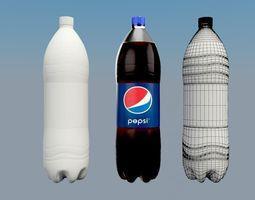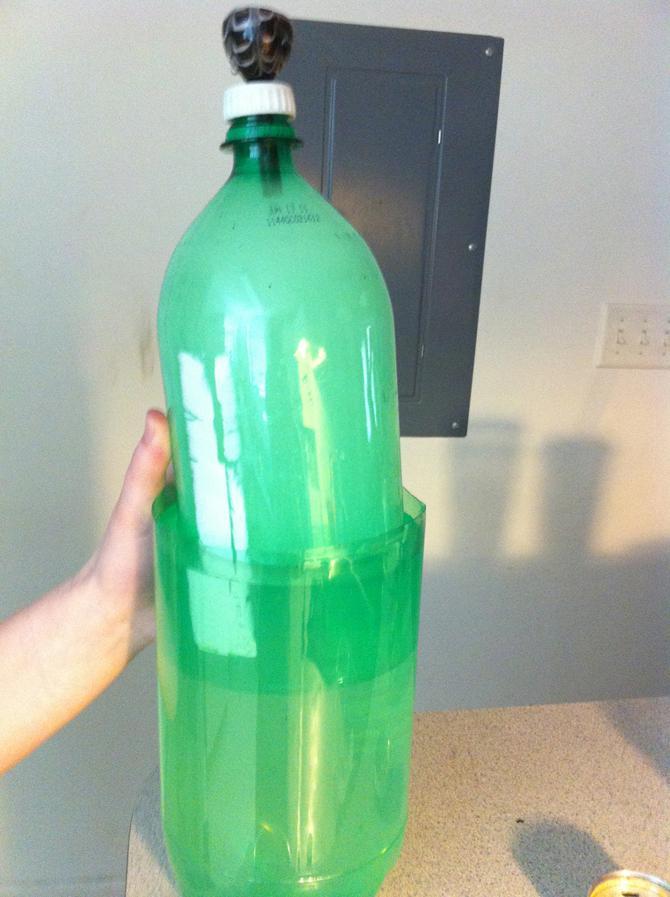The first image is the image on the left, the second image is the image on the right. Assess this claim about the two images: "There are two glass full of the liquad from the soda bottle behind them.". Correct or not? Answer yes or no. No. The first image is the image on the left, the second image is the image on the right. For the images shown, is this caption "In the left image there are exactly two bottles with soda in them." true? Answer yes or no. No. 